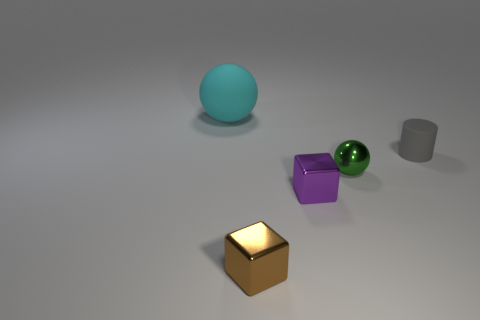Add 4 metal things. How many objects exist? 9 Subtract all cylinders. How many objects are left? 4 Subtract 0 red cylinders. How many objects are left? 5 Subtract all large matte objects. Subtract all small brown cylinders. How many objects are left? 4 Add 2 spheres. How many spheres are left? 4 Add 5 small yellow cubes. How many small yellow cubes exist? 5 